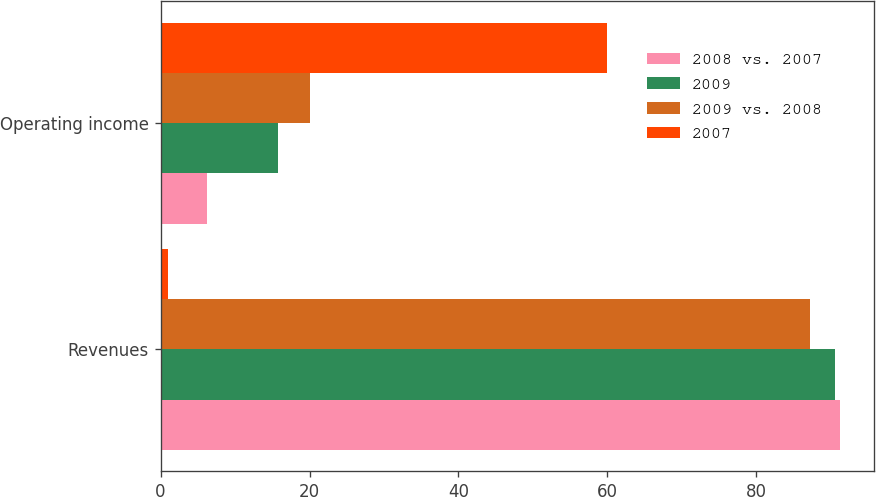Convert chart to OTSL. <chart><loc_0><loc_0><loc_500><loc_500><stacked_bar_chart><ecel><fcel>Revenues<fcel>Operating income<nl><fcel>2008 vs. 2007<fcel>91.2<fcel>6.3<nl><fcel>2009<fcel>90.6<fcel>15.8<nl><fcel>2009 vs. 2008<fcel>87.2<fcel>20<nl><fcel>2007<fcel>1<fcel>60<nl></chart> 